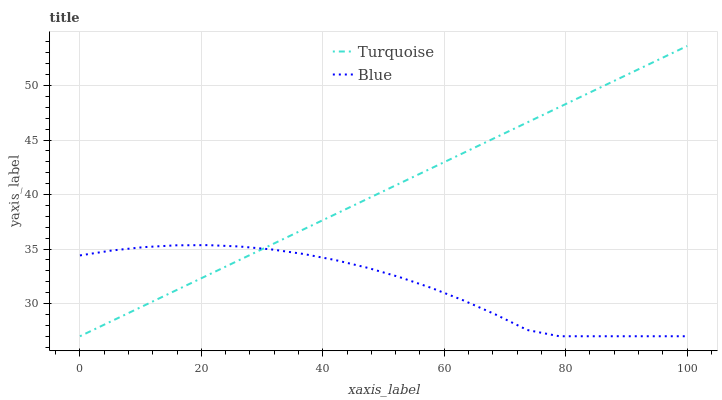Does Blue have the minimum area under the curve?
Answer yes or no. Yes. Does Turquoise have the maximum area under the curve?
Answer yes or no. Yes. Does Turquoise have the minimum area under the curve?
Answer yes or no. No. Is Turquoise the smoothest?
Answer yes or no. Yes. Is Blue the roughest?
Answer yes or no. Yes. Is Turquoise the roughest?
Answer yes or no. No. Does Blue have the lowest value?
Answer yes or no. Yes. Does Turquoise have the highest value?
Answer yes or no. Yes. Does Turquoise intersect Blue?
Answer yes or no. Yes. Is Turquoise less than Blue?
Answer yes or no. No. Is Turquoise greater than Blue?
Answer yes or no. No. 